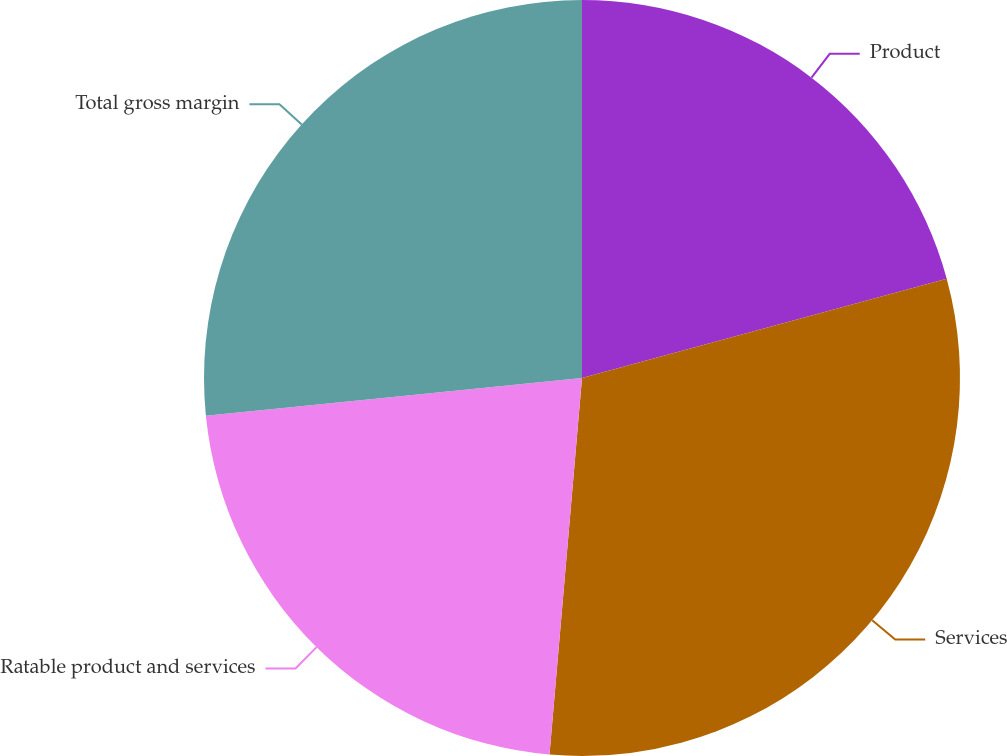Convert chart. <chart><loc_0><loc_0><loc_500><loc_500><pie_chart><fcel>Product<fcel>Services<fcel>Ratable product and services<fcel>Total gross margin<nl><fcel>20.77%<fcel>30.6%<fcel>22.04%<fcel>26.59%<nl></chart> 